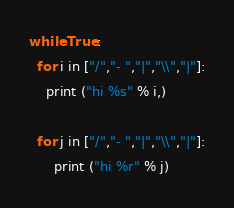Convert code to text. <code><loc_0><loc_0><loc_500><loc_500><_Python_>while True:
  for i in ["/","- ","|","\\","|"]:
    print ("hi %s" % i,)
	
  for j in ["/","- ","|","\\","|"]:
	  print ("hi %r" % j)</code> 